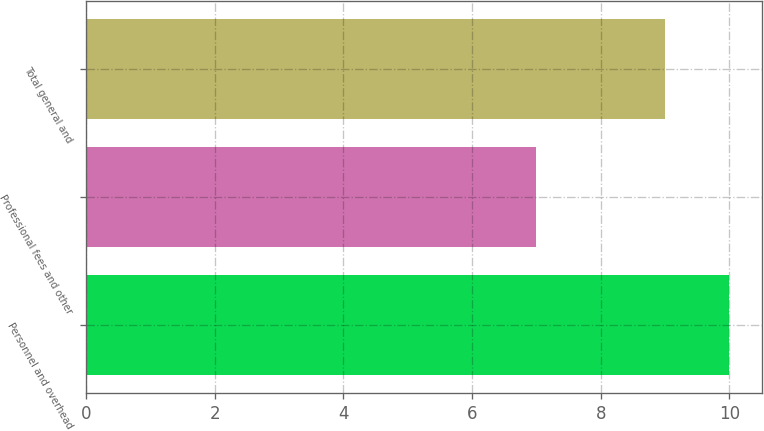Convert chart to OTSL. <chart><loc_0><loc_0><loc_500><loc_500><bar_chart><fcel>Personnel and overhead<fcel>Professional fees and other<fcel>Total general and<nl><fcel>10<fcel>7<fcel>9<nl></chart> 